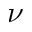<formula> <loc_0><loc_0><loc_500><loc_500>\nu</formula> 